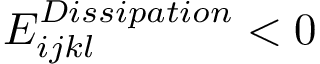<formula> <loc_0><loc_0><loc_500><loc_500>E _ { i j k l } ^ { D i s s i p a t i o n } < 0</formula> 